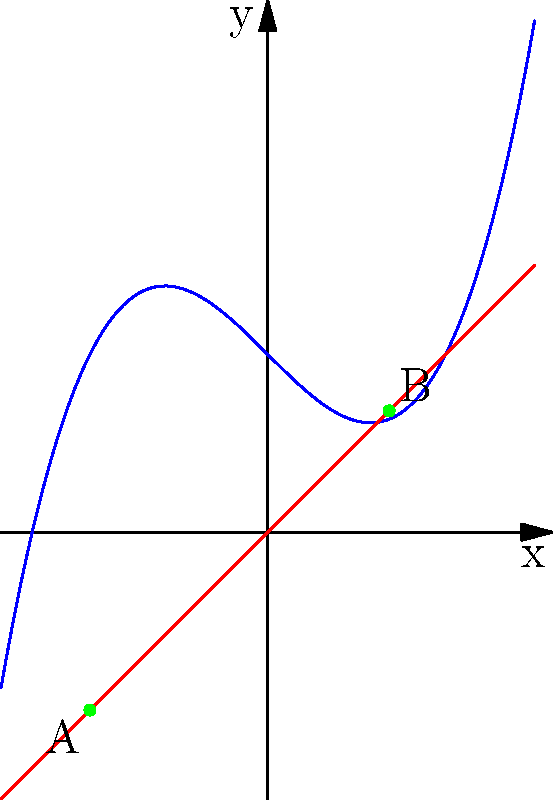In the context of using fixed point theorems to understand stability in healing processes, consider the function $f(x) = x^3 - x + 1$ represented by the blue curve. Which of the fixed points (A or B) represents a more stable state in the healing journey, and why? To understand which fixed point represents a more stable state in the healing journey, we need to analyze the behavior of the function near each fixed point:

1. Identify the fixed points:
   Fixed points occur where $f(x) = x$, i.e., where the blue curve intersects the red line $y = x$.
   Point A: $(-1, -1)$
   Point B: $(0.682328, 0.682328)$

2. Analyze stability:
   a) For point A:
      - Slope of $f(x)$ at $x = -1$ is $f'(-1) = 3(-1)^2 - 1 = 2$
      - Since $|f'(-1)| > 1$, small deviations from this point will grow larger.
      - This represents an unstable fixed point.

   b) For point B:
      - Slope of $f(x)$ at $x ≈ 0.682328$ is $f'(0.682328) ≈ 0.4$
      - Since $|f'(0.682328)| < 1$, small deviations from this point will diminish.
      - This represents a stable fixed point.

3. Interpretation for healing:
   - Point A (unstable): Represents a fragile state in the healing process, where small disturbances can lead to significant setbacks.
   - Point B (stable): Represents a resilient state in the healing journey, where minor setbacks are more easily overcome.

Therefore, point B represents a more stable state in the healing journey, as it allows for better recovery from small disturbances, which is crucial for long-term progress in trauma recovery.
Answer: Point B (stable fixed point) 